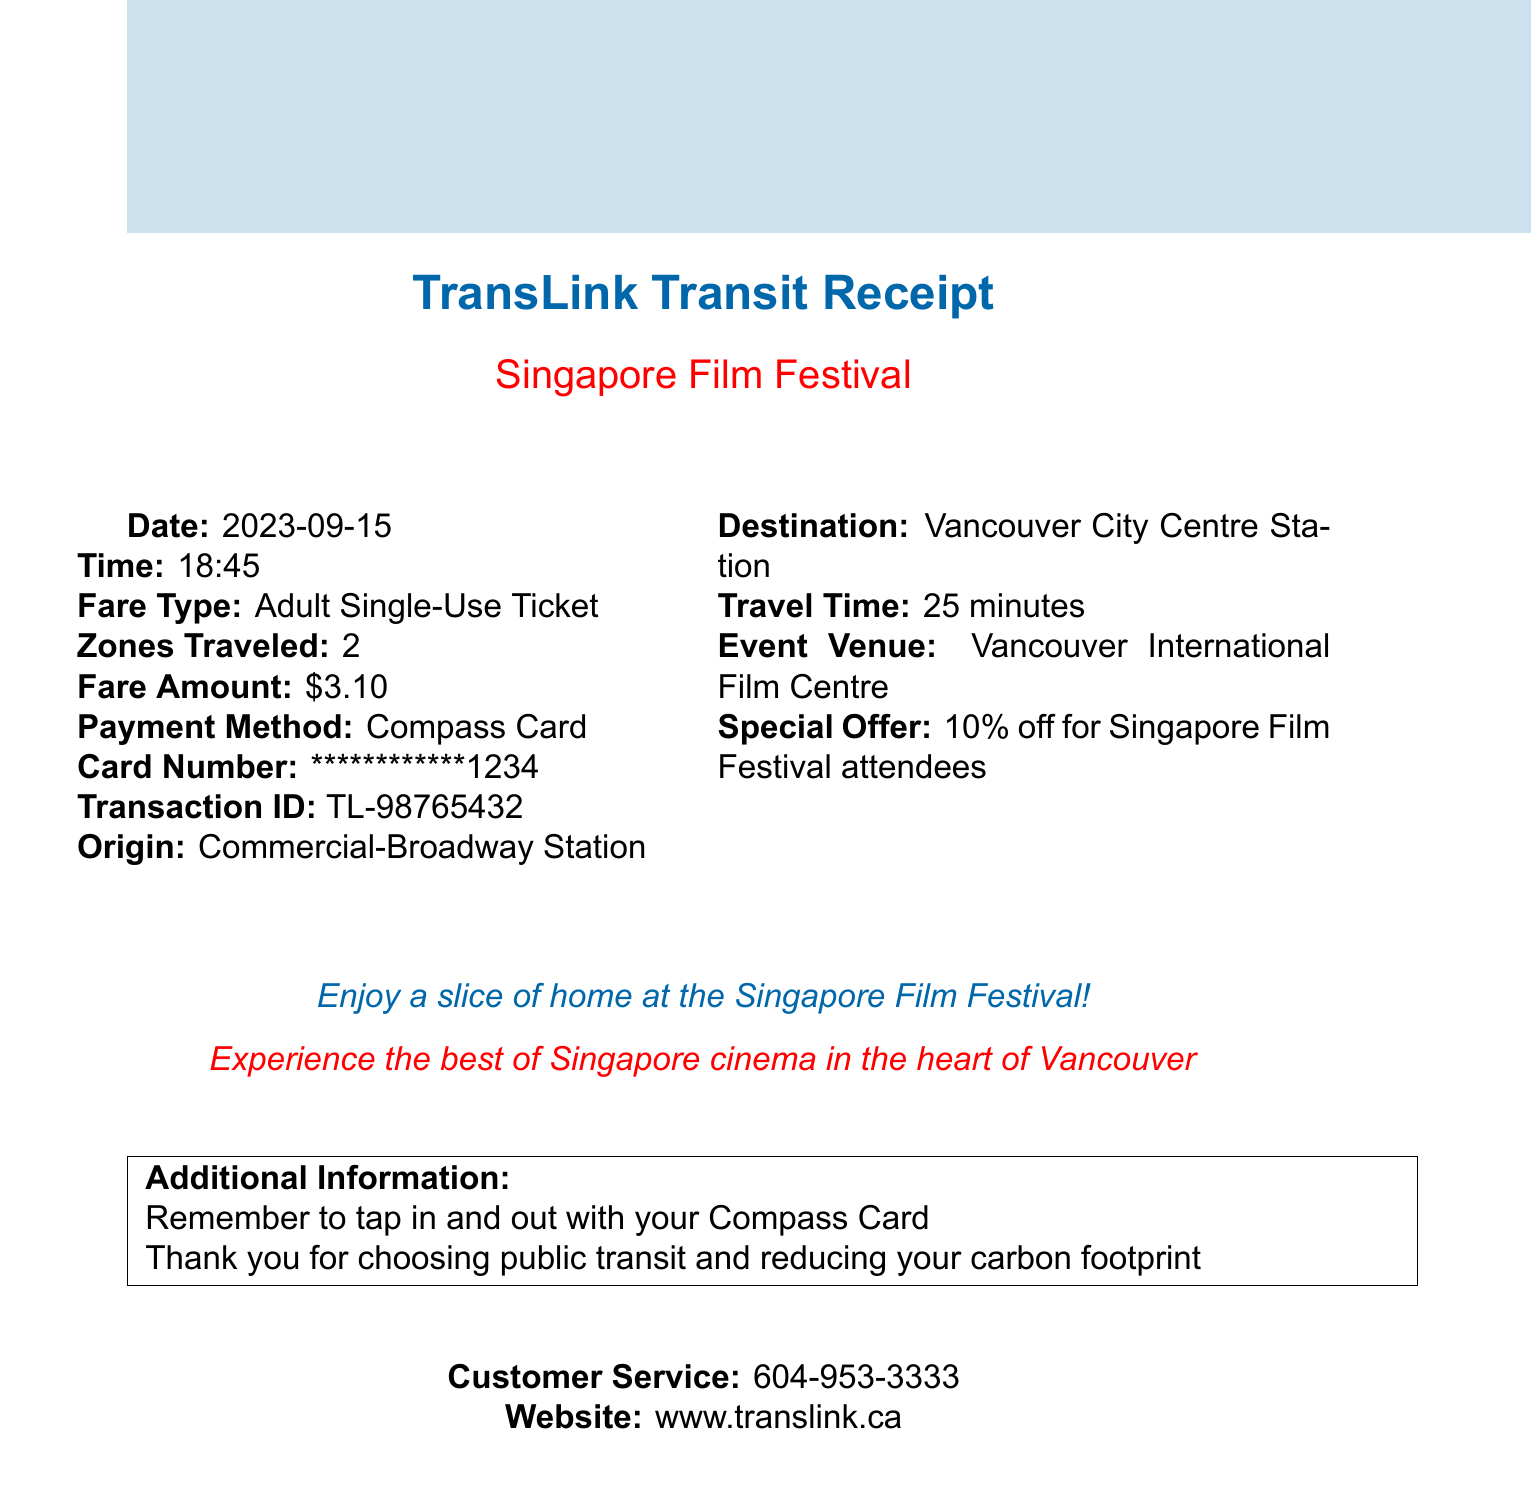What is the transit agency? The document specifies that the transit agency is responsible for the services provided, which is TransLink.
Answer: TransLink What is the fare type? The document indicates the kind of ticket purchased for travel, which is an Adult Single-Use Ticket.
Answer: Adult Single-Use Ticket What was the fare amount? The document states the cost of the ticket purchased, which is clearly indicated as a dollar amount.
Answer: $3.10 What is the origin station? The document provides information on where the journey began, which is Commercial-Broadway Station.
Answer: Commercial-Broadway Station How long was the travel time? The document includes the duration it took to get from the origin to the destination station, listed as a time frame.
Answer: 25 minutes What event is this receipt for? The document details that the transportation is in relation to a specific cultural event, which is named in the text.
Answer: Singapore Film Festival What special offer is mentioned? The document includes a promotional detail related to ticket pricing for the event attendees, which is stated as a percentage discount.
Answer: 10% off for Singapore Film Festival attendees What is the customer service number? The document provides a contact number for assistance, which is important for customer inquiries.
Answer: 604-953-3333 Why should customers remember to tap in and out? The document includes an instruction regarding the use of the Compass Card to ensure proper fare logging for transit use.
Answer: To ensure proper fare logging 